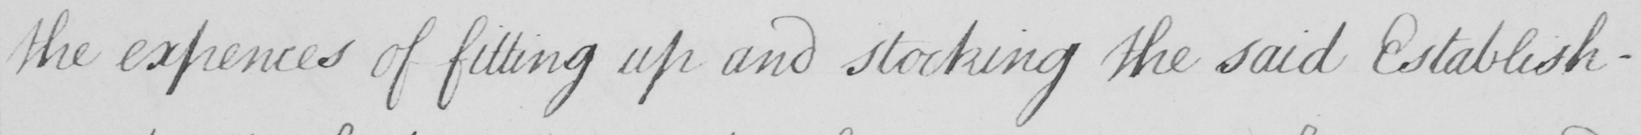What is written in this line of handwriting? the expences of fitting up and stocking the said Establish- 